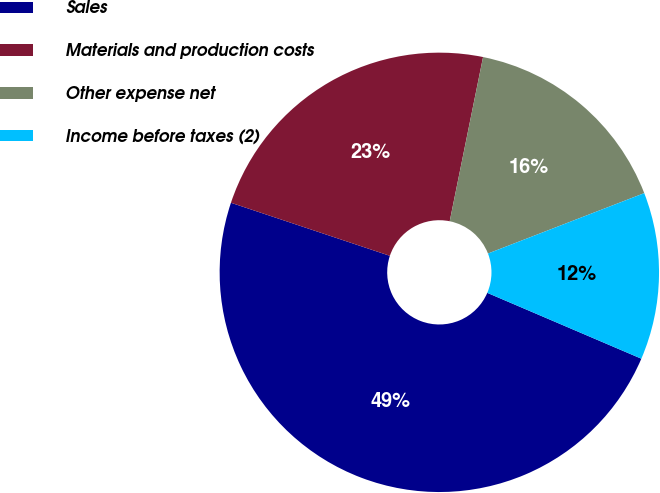<chart> <loc_0><loc_0><loc_500><loc_500><pie_chart><fcel>Sales<fcel>Materials and production costs<fcel>Other expense net<fcel>Income before taxes (2)<nl><fcel>48.7%<fcel>23.06%<fcel>15.94%<fcel>12.3%<nl></chart> 